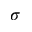Convert formula to latex. <formula><loc_0><loc_0><loc_500><loc_500>\sigma</formula> 